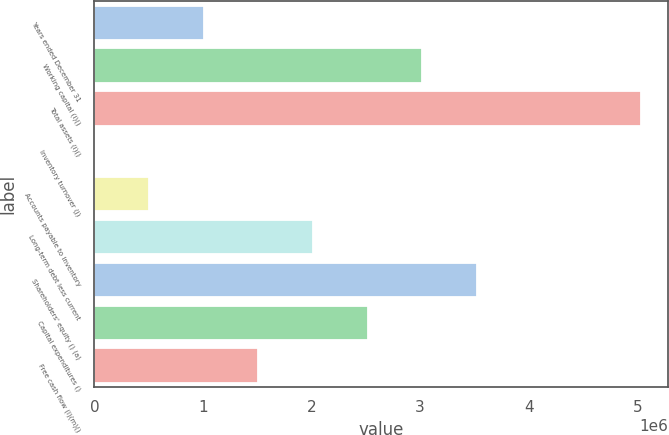Convert chart. <chart><loc_0><loc_0><loc_500><loc_500><bar_chart><fcel>Years ended December 31<fcel>Working capital (i)()<fcel>Total assets (i)()<fcel>Inventory turnover (j)<fcel>Accounts payable to inventory<fcel>Long-term debt less current<fcel>Shareholders' equity () (a)<fcel>Capital expenditures ()<fcel>Free cash flow (l)(m)()<nl><fcel>1.00639e+06<fcel>3.01917e+06<fcel>5.03195e+06<fcel>1.4<fcel>503196<fcel>2.01278e+06<fcel>3.52237e+06<fcel>2.51598e+06<fcel>1.50959e+06<nl></chart> 